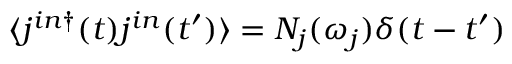Convert formula to latex. <formula><loc_0><loc_0><loc_500><loc_500>\langle j ^ { i n \dagger } ( t ) j ^ { i n } ( t ^ { \prime } ) \rangle = N _ { j } ( \omega _ { j } ) \delta ( t - t ^ { \prime } )</formula> 